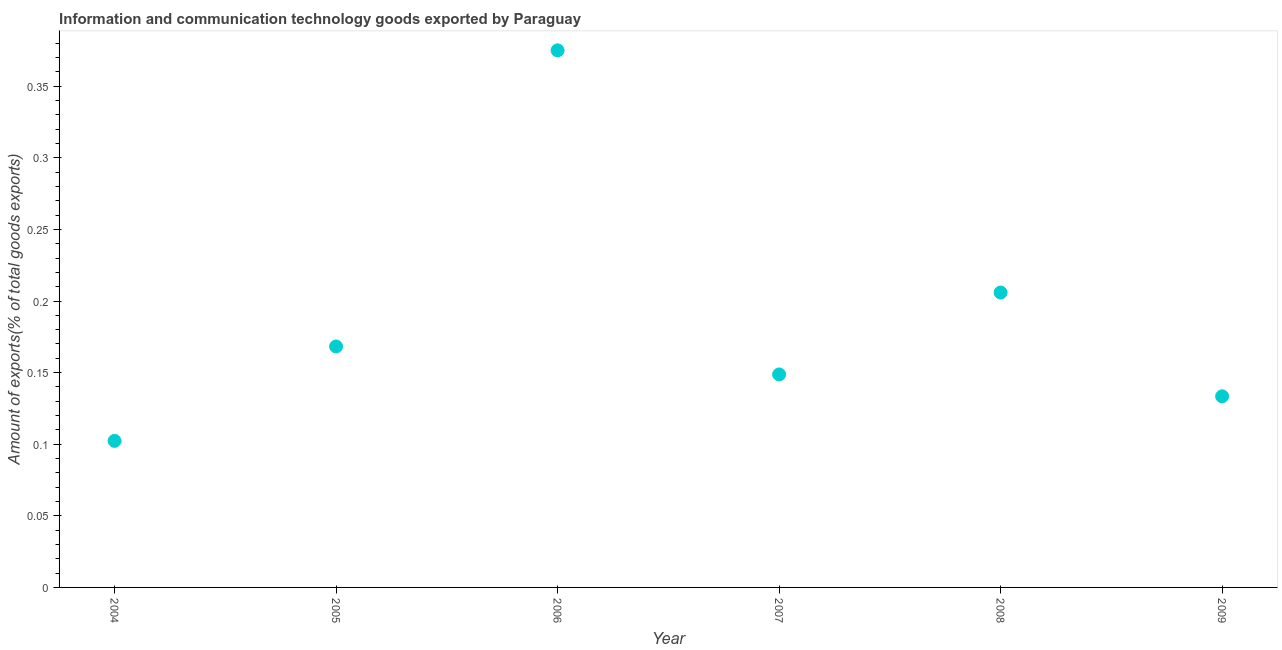What is the amount of ict goods exports in 2008?
Offer a very short reply. 0.21. Across all years, what is the maximum amount of ict goods exports?
Make the answer very short. 0.38. Across all years, what is the minimum amount of ict goods exports?
Give a very brief answer. 0.1. In which year was the amount of ict goods exports maximum?
Provide a short and direct response. 2006. In which year was the amount of ict goods exports minimum?
Offer a very short reply. 2004. What is the sum of the amount of ict goods exports?
Provide a short and direct response. 1.13. What is the difference between the amount of ict goods exports in 2004 and 2006?
Offer a terse response. -0.27. What is the average amount of ict goods exports per year?
Provide a succinct answer. 0.19. What is the median amount of ict goods exports?
Make the answer very short. 0.16. In how many years, is the amount of ict goods exports greater than 0.09 %?
Ensure brevity in your answer.  6. What is the ratio of the amount of ict goods exports in 2007 to that in 2008?
Offer a very short reply. 0.72. Is the amount of ict goods exports in 2005 less than that in 2007?
Your response must be concise. No. What is the difference between the highest and the second highest amount of ict goods exports?
Your response must be concise. 0.17. Is the sum of the amount of ict goods exports in 2005 and 2009 greater than the maximum amount of ict goods exports across all years?
Keep it short and to the point. No. What is the difference between the highest and the lowest amount of ict goods exports?
Your response must be concise. 0.27. What is the difference between two consecutive major ticks on the Y-axis?
Offer a very short reply. 0.05. Are the values on the major ticks of Y-axis written in scientific E-notation?
Your response must be concise. No. Does the graph contain grids?
Your response must be concise. No. What is the title of the graph?
Make the answer very short. Information and communication technology goods exported by Paraguay. What is the label or title of the Y-axis?
Offer a terse response. Amount of exports(% of total goods exports). What is the Amount of exports(% of total goods exports) in 2004?
Your answer should be compact. 0.1. What is the Amount of exports(% of total goods exports) in 2005?
Provide a short and direct response. 0.17. What is the Amount of exports(% of total goods exports) in 2006?
Ensure brevity in your answer.  0.38. What is the Amount of exports(% of total goods exports) in 2007?
Offer a very short reply. 0.15. What is the Amount of exports(% of total goods exports) in 2008?
Provide a succinct answer. 0.21. What is the Amount of exports(% of total goods exports) in 2009?
Keep it short and to the point. 0.13. What is the difference between the Amount of exports(% of total goods exports) in 2004 and 2005?
Your response must be concise. -0.07. What is the difference between the Amount of exports(% of total goods exports) in 2004 and 2006?
Provide a succinct answer. -0.27. What is the difference between the Amount of exports(% of total goods exports) in 2004 and 2007?
Your answer should be very brief. -0.05. What is the difference between the Amount of exports(% of total goods exports) in 2004 and 2008?
Provide a short and direct response. -0.1. What is the difference between the Amount of exports(% of total goods exports) in 2004 and 2009?
Give a very brief answer. -0.03. What is the difference between the Amount of exports(% of total goods exports) in 2005 and 2006?
Offer a very short reply. -0.21. What is the difference between the Amount of exports(% of total goods exports) in 2005 and 2007?
Offer a very short reply. 0.02. What is the difference between the Amount of exports(% of total goods exports) in 2005 and 2008?
Your response must be concise. -0.04. What is the difference between the Amount of exports(% of total goods exports) in 2005 and 2009?
Your response must be concise. 0.03. What is the difference between the Amount of exports(% of total goods exports) in 2006 and 2007?
Offer a terse response. 0.23. What is the difference between the Amount of exports(% of total goods exports) in 2006 and 2008?
Your answer should be compact. 0.17. What is the difference between the Amount of exports(% of total goods exports) in 2006 and 2009?
Make the answer very short. 0.24. What is the difference between the Amount of exports(% of total goods exports) in 2007 and 2008?
Provide a short and direct response. -0.06. What is the difference between the Amount of exports(% of total goods exports) in 2007 and 2009?
Give a very brief answer. 0.02. What is the difference between the Amount of exports(% of total goods exports) in 2008 and 2009?
Offer a terse response. 0.07. What is the ratio of the Amount of exports(% of total goods exports) in 2004 to that in 2005?
Provide a short and direct response. 0.61. What is the ratio of the Amount of exports(% of total goods exports) in 2004 to that in 2006?
Your answer should be very brief. 0.27. What is the ratio of the Amount of exports(% of total goods exports) in 2004 to that in 2007?
Your answer should be compact. 0.69. What is the ratio of the Amount of exports(% of total goods exports) in 2004 to that in 2008?
Ensure brevity in your answer.  0.5. What is the ratio of the Amount of exports(% of total goods exports) in 2004 to that in 2009?
Your response must be concise. 0.77. What is the ratio of the Amount of exports(% of total goods exports) in 2005 to that in 2006?
Your answer should be very brief. 0.45. What is the ratio of the Amount of exports(% of total goods exports) in 2005 to that in 2007?
Your answer should be very brief. 1.13. What is the ratio of the Amount of exports(% of total goods exports) in 2005 to that in 2008?
Your answer should be compact. 0.82. What is the ratio of the Amount of exports(% of total goods exports) in 2005 to that in 2009?
Keep it short and to the point. 1.26. What is the ratio of the Amount of exports(% of total goods exports) in 2006 to that in 2007?
Your answer should be compact. 2.52. What is the ratio of the Amount of exports(% of total goods exports) in 2006 to that in 2008?
Provide a short and direct response. 1.82. What is the ratio of the Amount of exports(% of total goods exports) in 2006 to that in 2009?
Keep it short and to the point. 2.81. What is the ratio of the Amount of exports(% of total goods exports) in 2007 to that in 2008?
Keep it short and to the point. 0.72. What is the ratio of the Amount of exports(% of total goods exports) in 2007 to that in 2009?
Offer a very short reply. 1.11. What is the ratio of the Amount of exports(% of total goods exports) in 2008 to that in 2009?
Offer a very short reply. 1.54. 